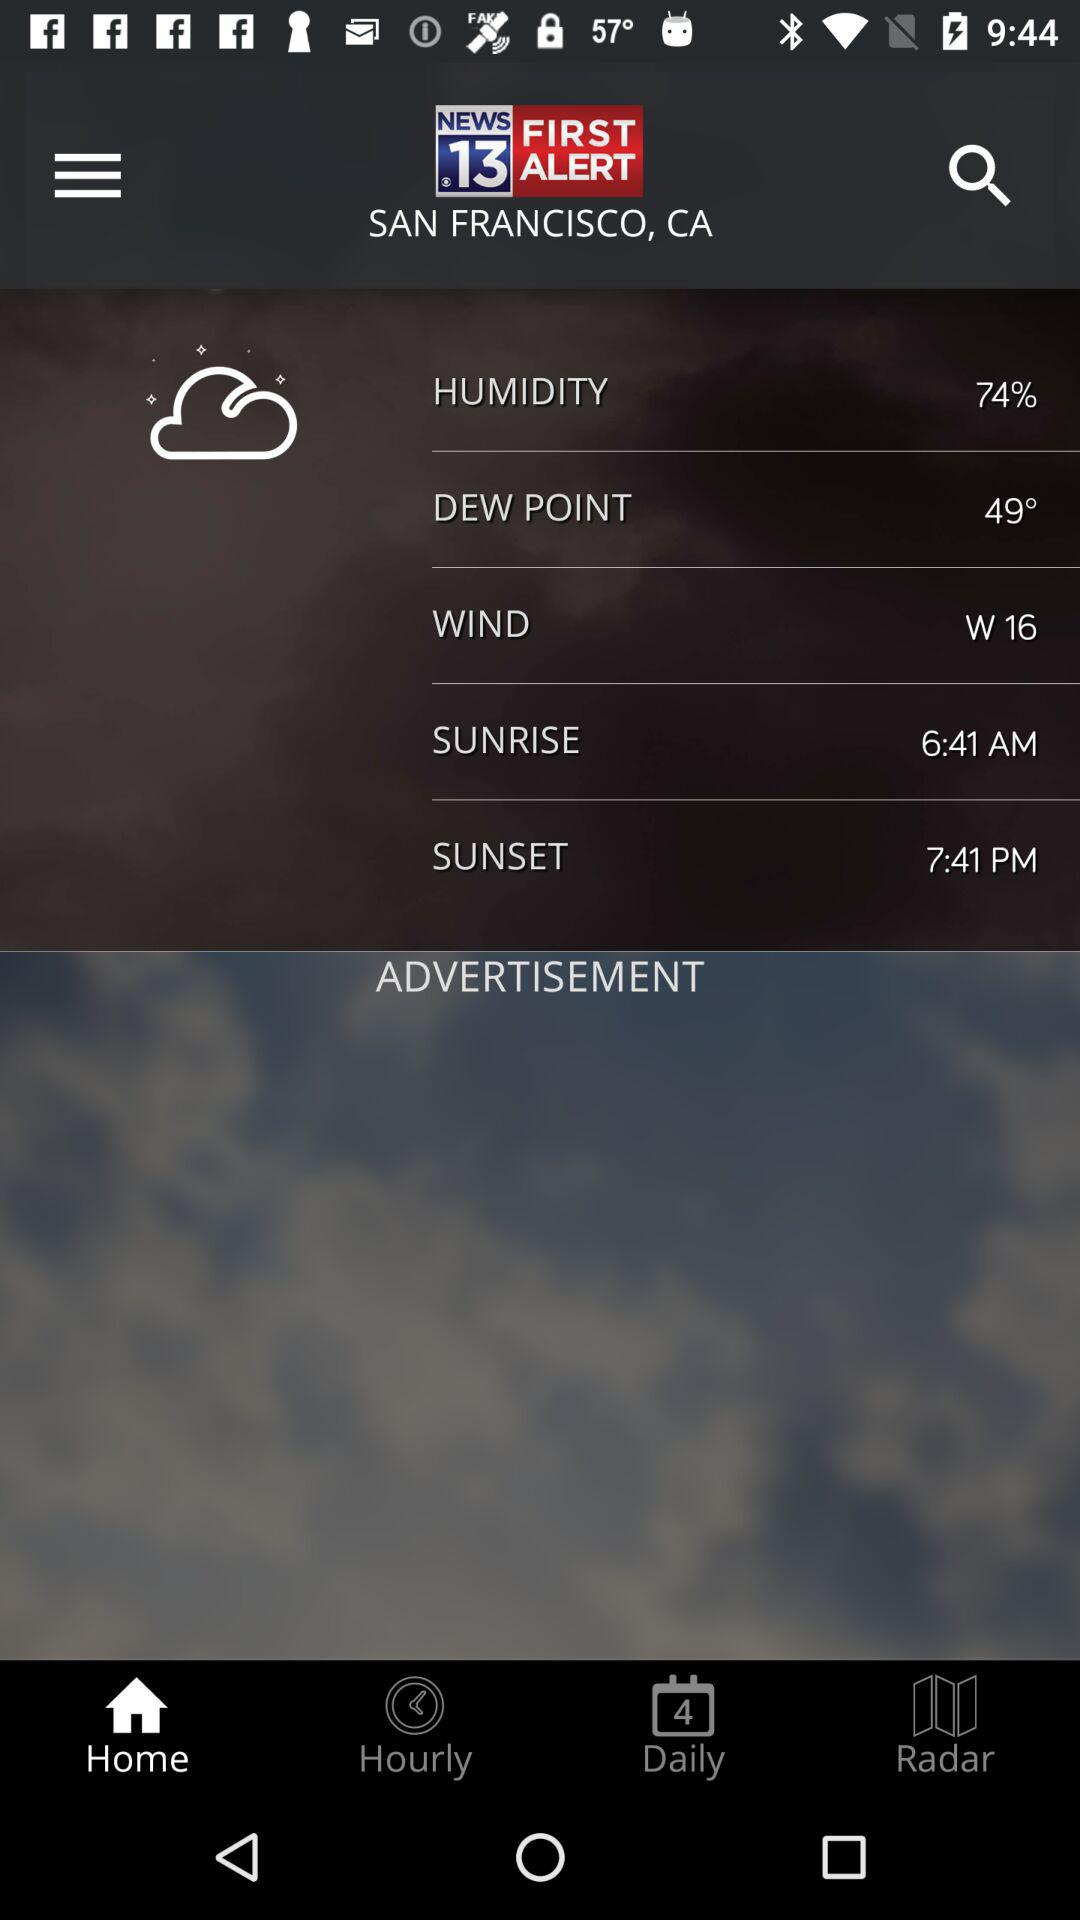How many hours are between sunrise and sunset?
Answer the question using a single word or phrase. 11 